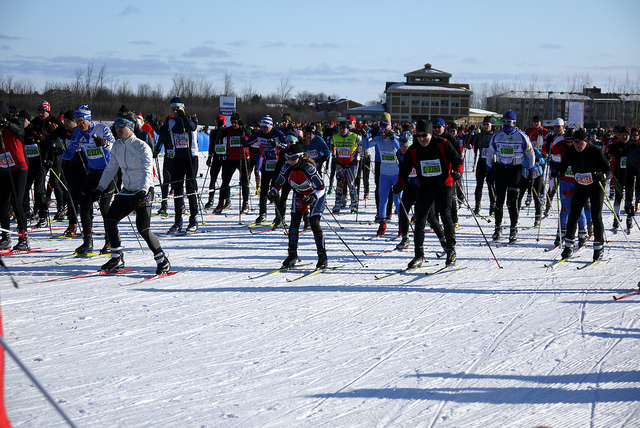Please transcribe the text in this image. C-2260 C-2204 